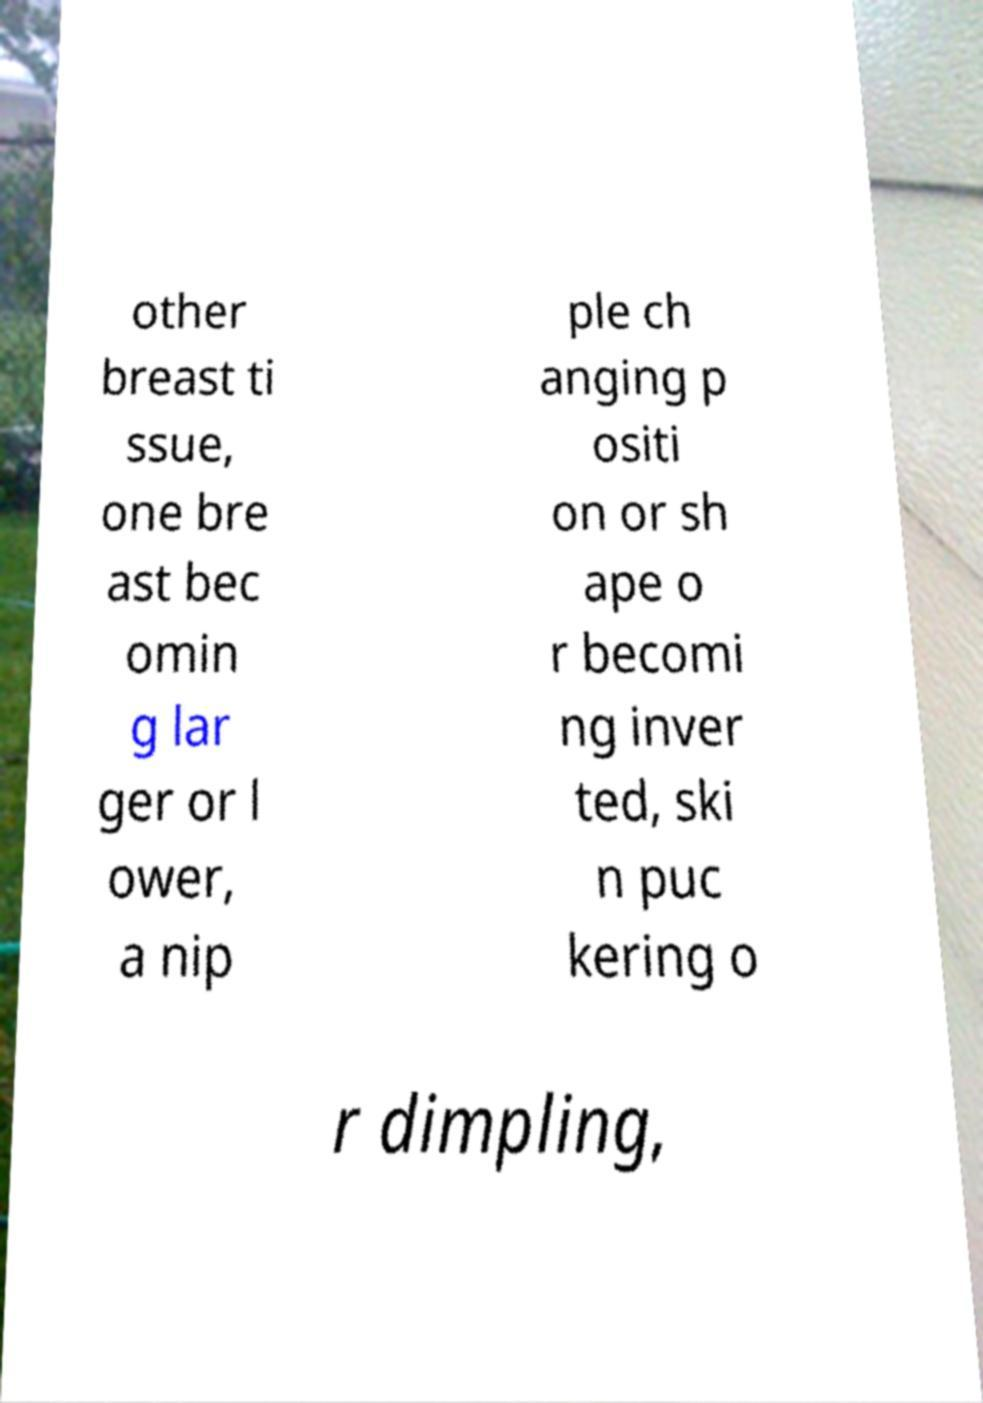What messages or text are displayed in this image? I need them in a readable, typed format. other breast ti ssue, one bre ast bec omin g lar ger or l ower, a nip ple ch anging p ositi on or sh ape o r becomi ng inver ted, ski n puc kering o r dimpling, 